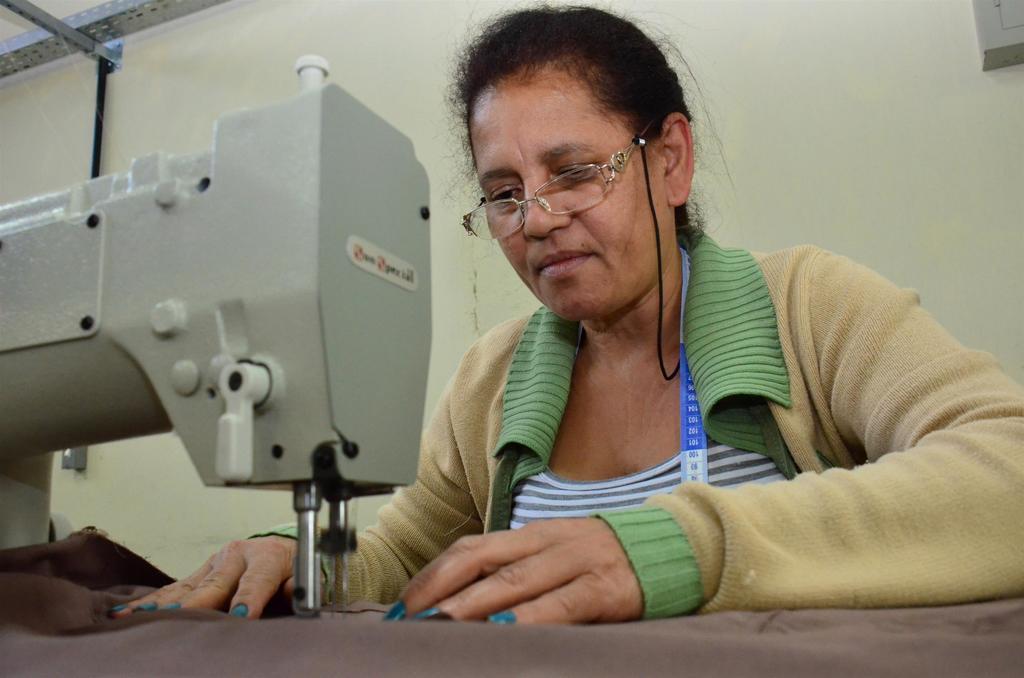Could you give a brief overview of what you see in this image? In this picture we can see a woman, sewing machine, cloth, measuring tape, spectacle and in the background we can see the wall and some objects. 